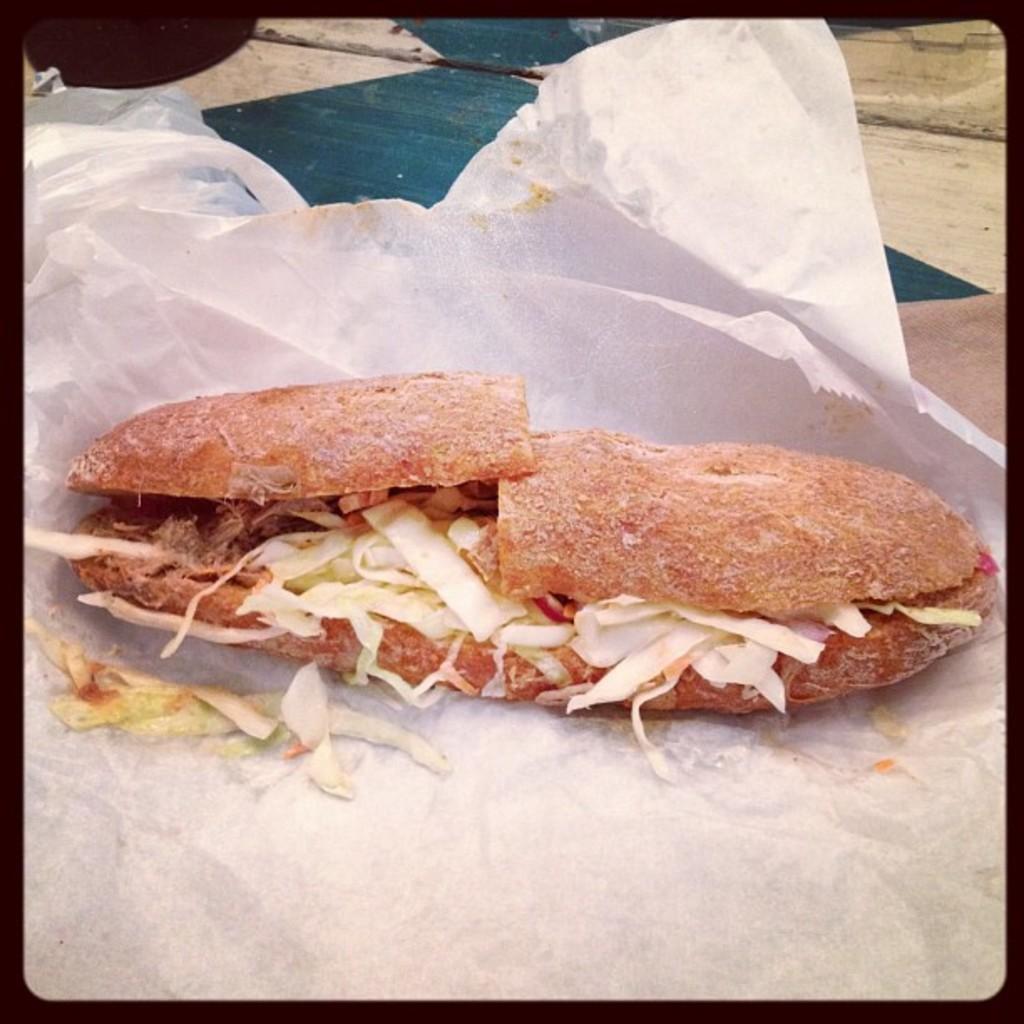Can you describe this image briefly? In this image we can see the picture of stuffed sandwich on the tissue. 